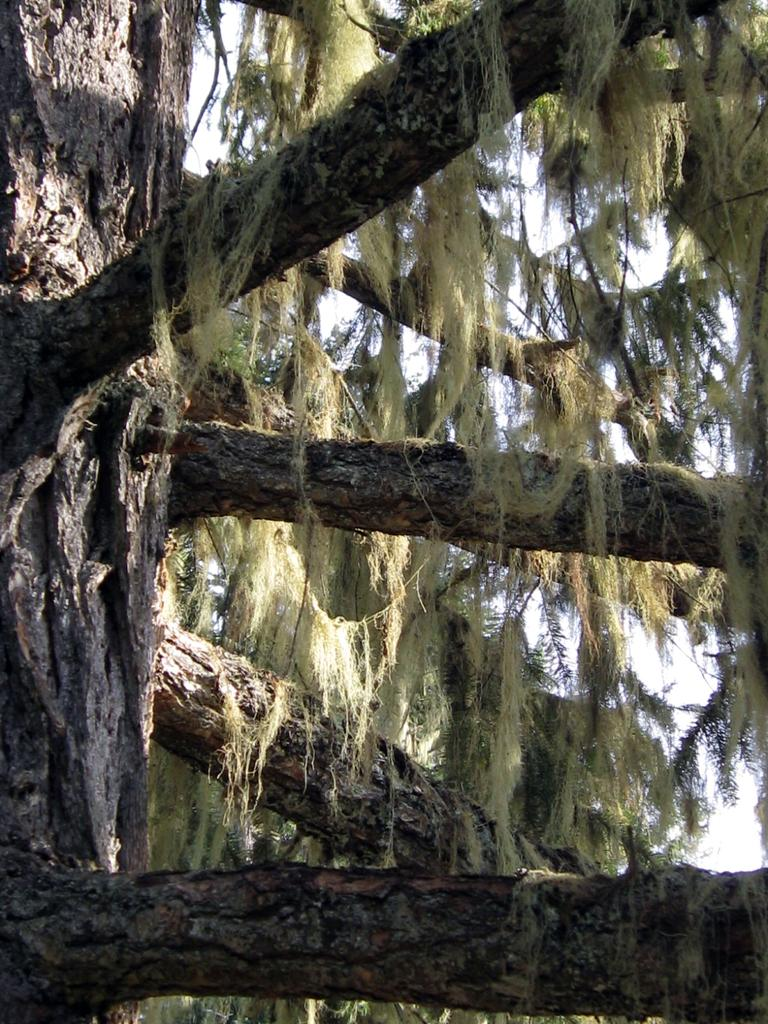What is the main subject of the image? The main subject of the image is a tree. Can you describe the colors of the tree? The tree has multiple colors, including ash, brown, black, and green. What can be seen in the background of the image? The sky is visible in the background of the image. How many glasses are on the tree in the image? There are no glasses present in the image; it features a tree with multiple colors. 